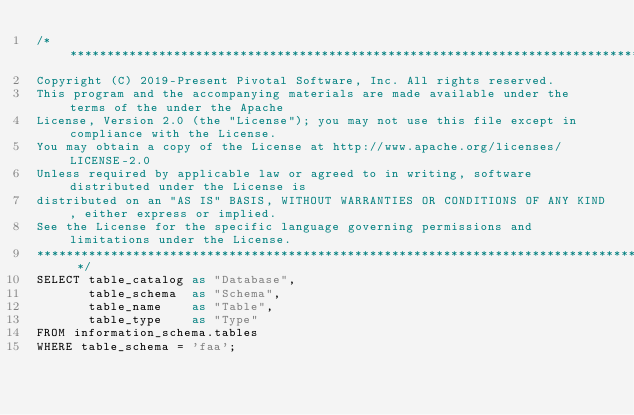<code> <loc_0><loc_0><loc_500><loc_500><_SQL_>/* *******************************************************************************************************
Copyright (C) 2019-Present Pivotal Software, Inc. All rights reserved.
This program and the accompanying materials are made available under the terms of the under the Apache
License, Version 2.0 (the "License"); you may not use this file except in compliance with the License.
You may obtain a copy of the License at http://www.apache.org/licenses/LICENSE-2.0
Unless required by applicable law or agreed to in writing, software distributed under the License is
distributed on an "AS IS" BASIS, WITHOUT WARRANTIES OR CONDITIONS OF ANY KIND, either express or implied.
See the License for the specific language governing permissions and limitations under the License.
******************************************************************************************************* */
SELECT table_catalog as "Database",
       table_schema  as "Schema",
       table_name    as "Table",
       table_type    as "Type"
FROM information_schema.tables 
WHERE table_schema = 'faa';
</code> 